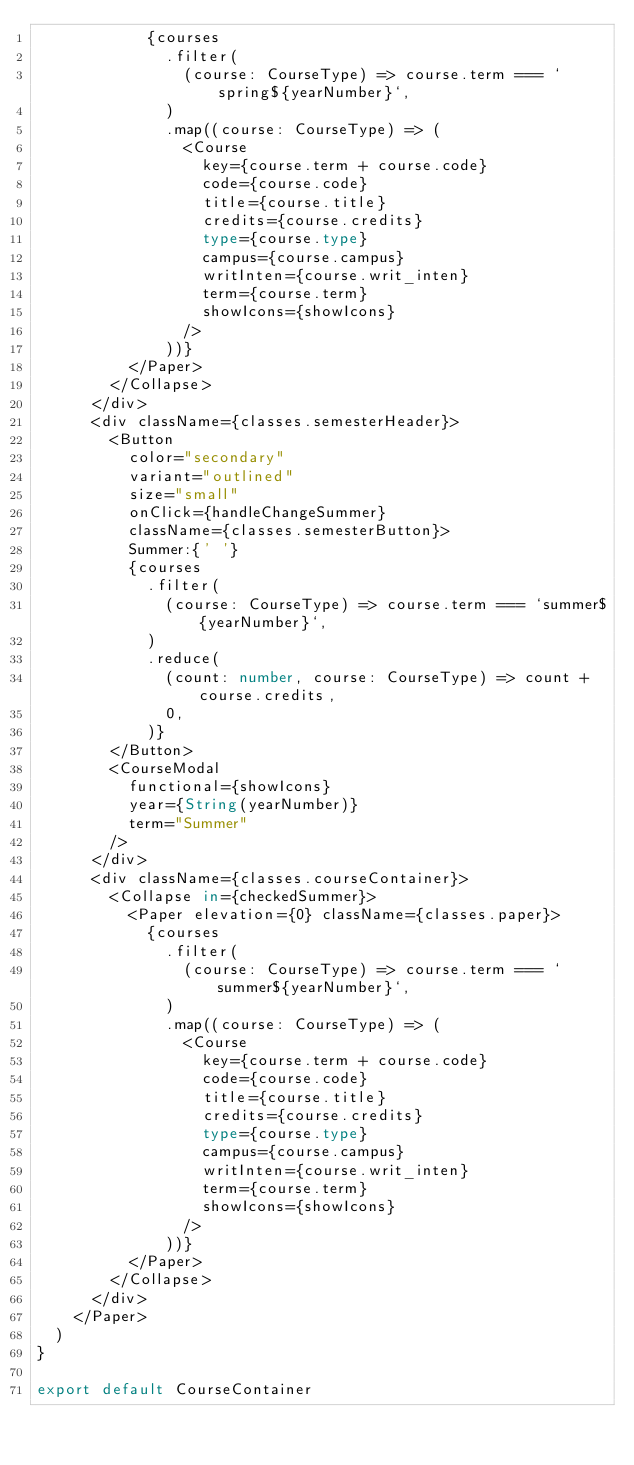<code> <loc_0><loc_0><loc_500><loc_500><_TypeScript_>            {courses
              .filter(
                (course: CourseType) => course.term === `spring${yearNumber}`,
              )
              .map((course: CourseType) => (
                <Course
                  key={course.term + course.code}
                  code={course.code}
                  title={course.title}
                  credits={course.credits}
                  type={course.type}
                  campus={course.campus}
                  writInten={course.writ_inten}
                  term={course.term}
                  showIcons={showIcons}
                />
              ))}
          </Paper>
        </Collapse>
      </div>
      <div className={classes.semesterHeader}>
        <Button
          color="secondary"
          variant="outlined"
          size="small"
          onClick={handleChangeSummer}
          className={classes.semesterButton}>
          Summer:{' '}
          {courses
            .filter(
              (course: CourseType) => course.term === `summer${yearNumber}`,
            )
            .reduce(
              (count: number, course: CourseType) => count + course.credits,
              0,
            )}
        </Button>
        <CourseModal
          functional={showIcons}
          year={String(yearNumber)}
          term="Summer"
        />
      </div>
      <div className={classes.courseContainer}>
        <Collapse in={checkedSummer}>
          <Paper elevation={0} className={classes.paper}>
            {courses
              .filter(
                (course: CourseType) => course.term === `summer${yearNumber}`,
              )
              .map((course: CourseType) => (
                <Course
                  key={course.term + course.code}
                  code={course.code}
                  title={course.title}
                  credits={course.credits}
                  type={course.type}
                  campus={course.campus}
                  writInten={course.writ_inten}
                  term={course.term}
                  showIcons={showIcons}
                />
              ))}
          </Paper>
        </Collapse>
      </div>
    </Paper>
  )
}

export default CourseContainer
</code> 